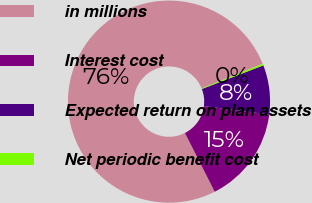Convert chart. <chart><loc_0><loc_0><loc_500><loc_500><pie_chart><fcel>in millions<fcel>Interest cost<fcel>Expected return on plan assets<fcel>Net periodic benefit cost<nl><fcel>76.37%<fcel>15.49%<fcel>7.88%<fcel>0.27%<nl></chart> 